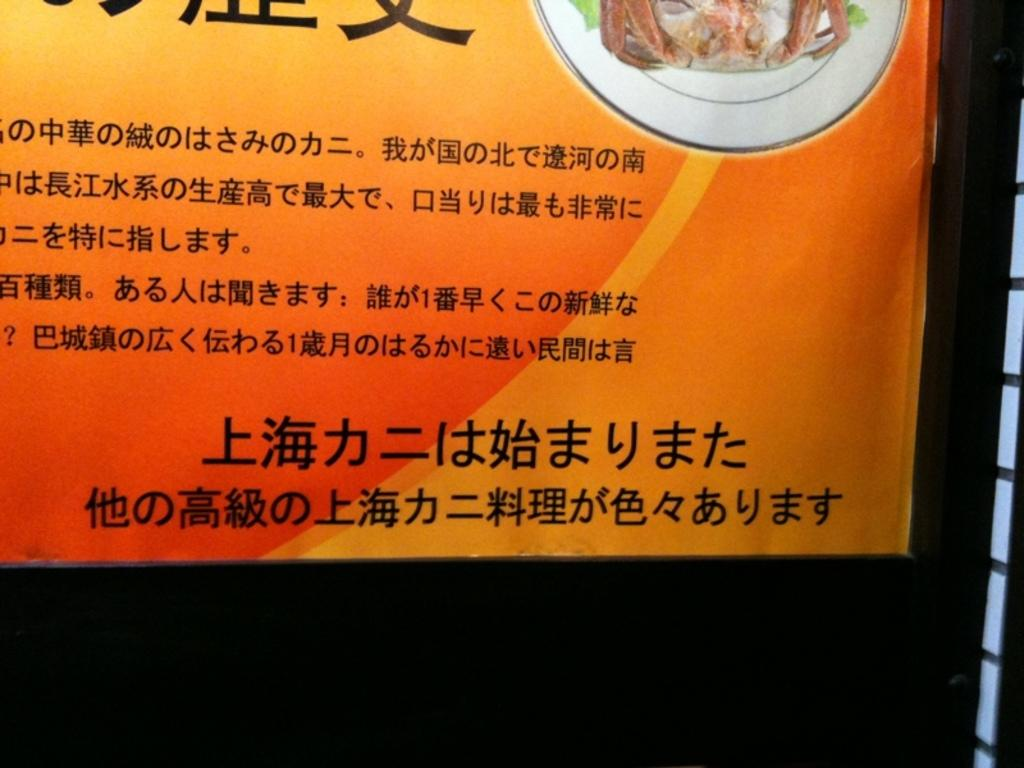What is located towards the top of the image? There is a banner in the image, and it is towards the top. What is written on the banner? There is text on the banner. What is on the plate in the image? There is food on the plate. What is the color of the background in the image? The background of the image is dark. Reasoning: Let's think step by following the steps to produce the conversation. We start by identifying the main subject in the image, which is the banner. Then, we expand the conversation to include other details about the banner, such as its position and the text on it. Next, we mention the plate and the food on it. Finally, we describe the background of the image. Each question is designed to elicit a specific detail about the image that is known from the provided facts. Absurd Question/Answer: What type of string is used to hang the cloud in the image? There is no cloud present in the image, and therefore no string is used to hang it. What type of string is used to hang the cloud in the image? There is no cloud present in the image, and therefore no string is used to hang it. 